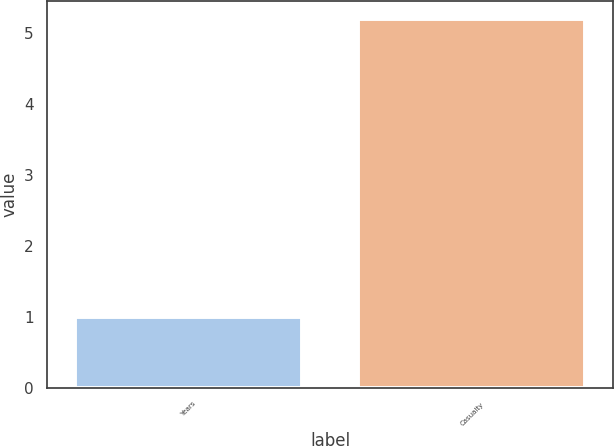<chart> <loc_0><loc_0><loc_500><loc_500><bar_chart><fcel>Years<fcel>Casualty<nl><fcel>1<fcel>5.2<nl></chart> 